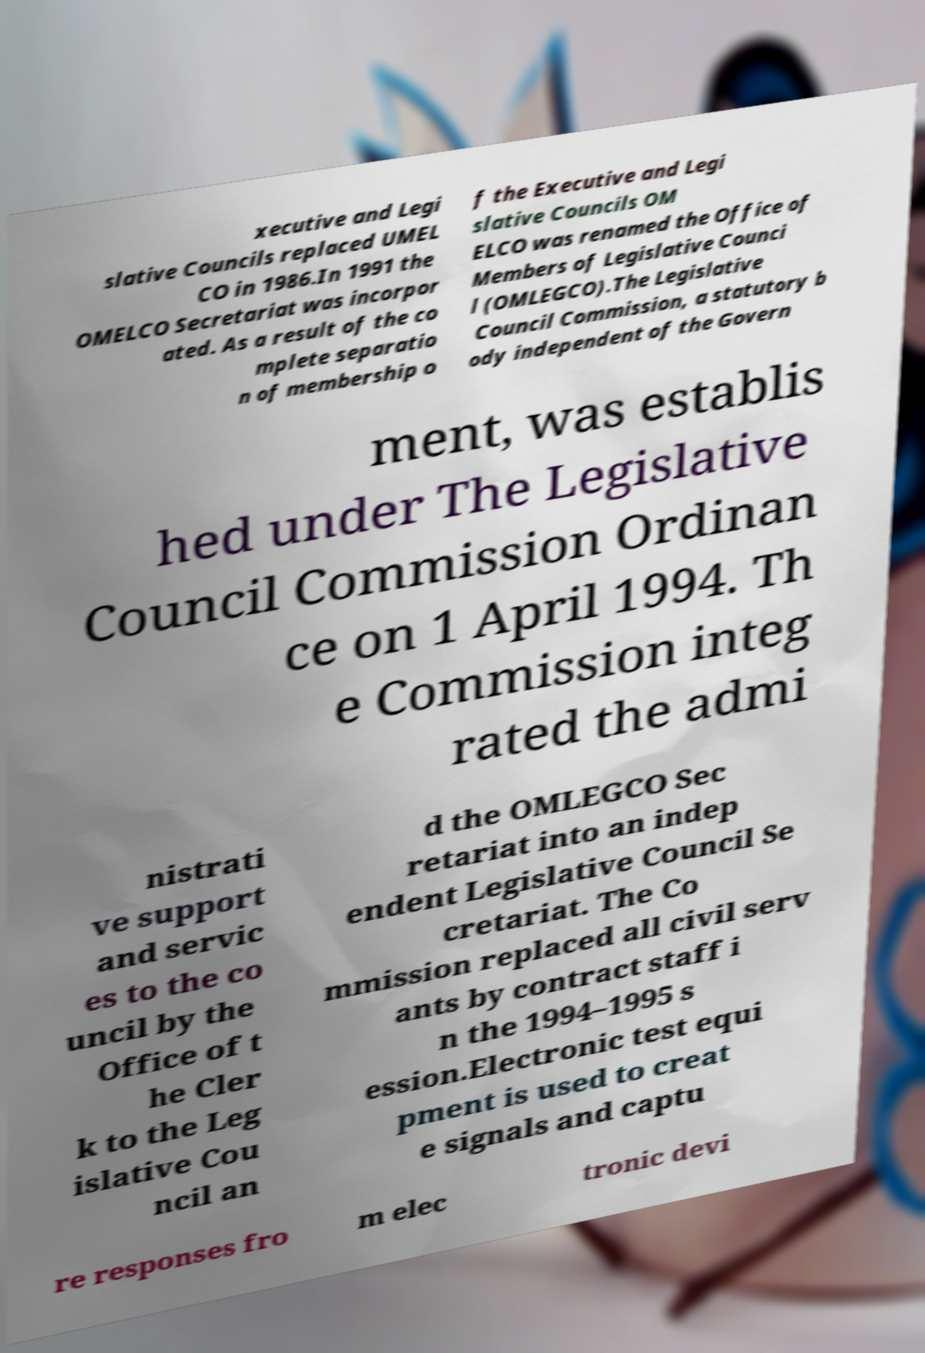Could you assist in decoding the text presented in this image and type it out clearly? xecutive and Legi slative Councils replaced UMEL CO in 1986.In 1991 the OMELCO Secretariat was incorpor ated. As a result of the co mplete separatio n of membership o f the Executive and Legi slative Councils OM ELCO was renamed the Office of Members of Legislative Counci l (OMLEGCO).The Legislative Council Commission, a statutory b ody independent of the Govern ment, was establis hed under The Legislative Council Commission Ordinan ce on 1 April 1994. Th e Commission integ rated the admi nistrati ve support and servic es to the co uncil by the Office of t he Cler k to the Leg islative Cou ncil an d the OMLEGCO Sec retariat into an indep endent Legislative Council Se cretariat. The Co mmission replaced all civil serv ants by contract staff i n the 1994–1995 s ession.Electronic test equi pment is used to creat e signals and captu re responses fro m elec tronic devi 